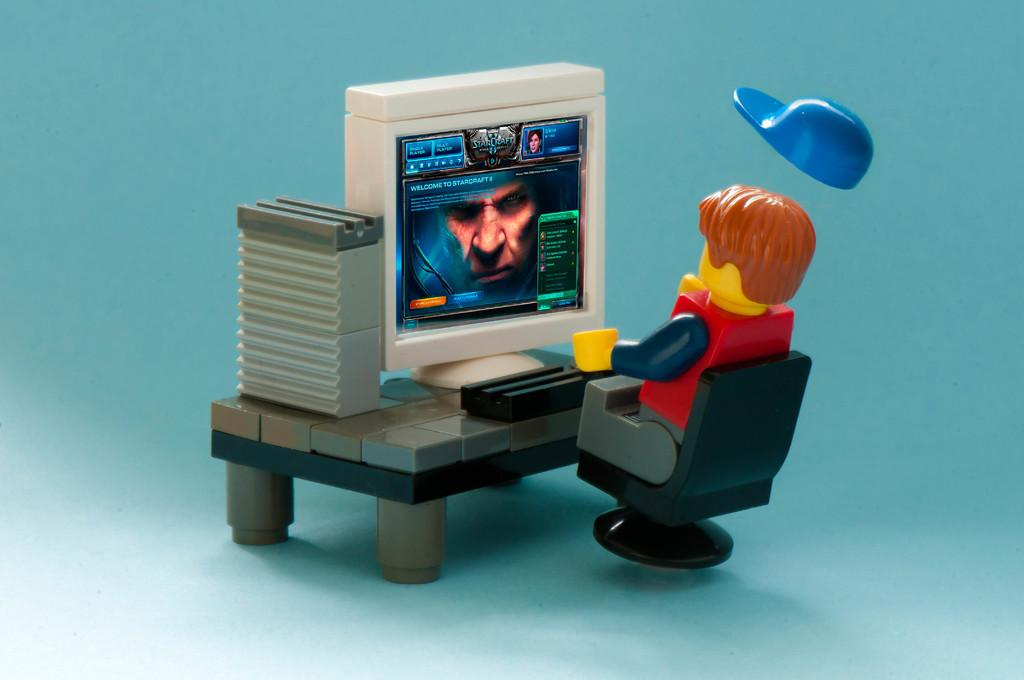What type of toy is visible in the image? There is a Lego toy in the image. Where is the Lego toy located? The Lego toy is sitting on a chair. What piece of furniture is present on the table in the image? There is a desktop on a table in the image. What type of clothing accessory is visible in the image? There is a cap in the image. What type of lunchroom is depicted in the image? There is no lunchroom present in the image; it features a Lego toy sitting on a chair, a desktop on a table, and a cap. What thrilling activity is taking place in the image? There is no thrilling activity depicted in the image; it is a still scene featuring a Lego toy, a desktop, and a cap. 